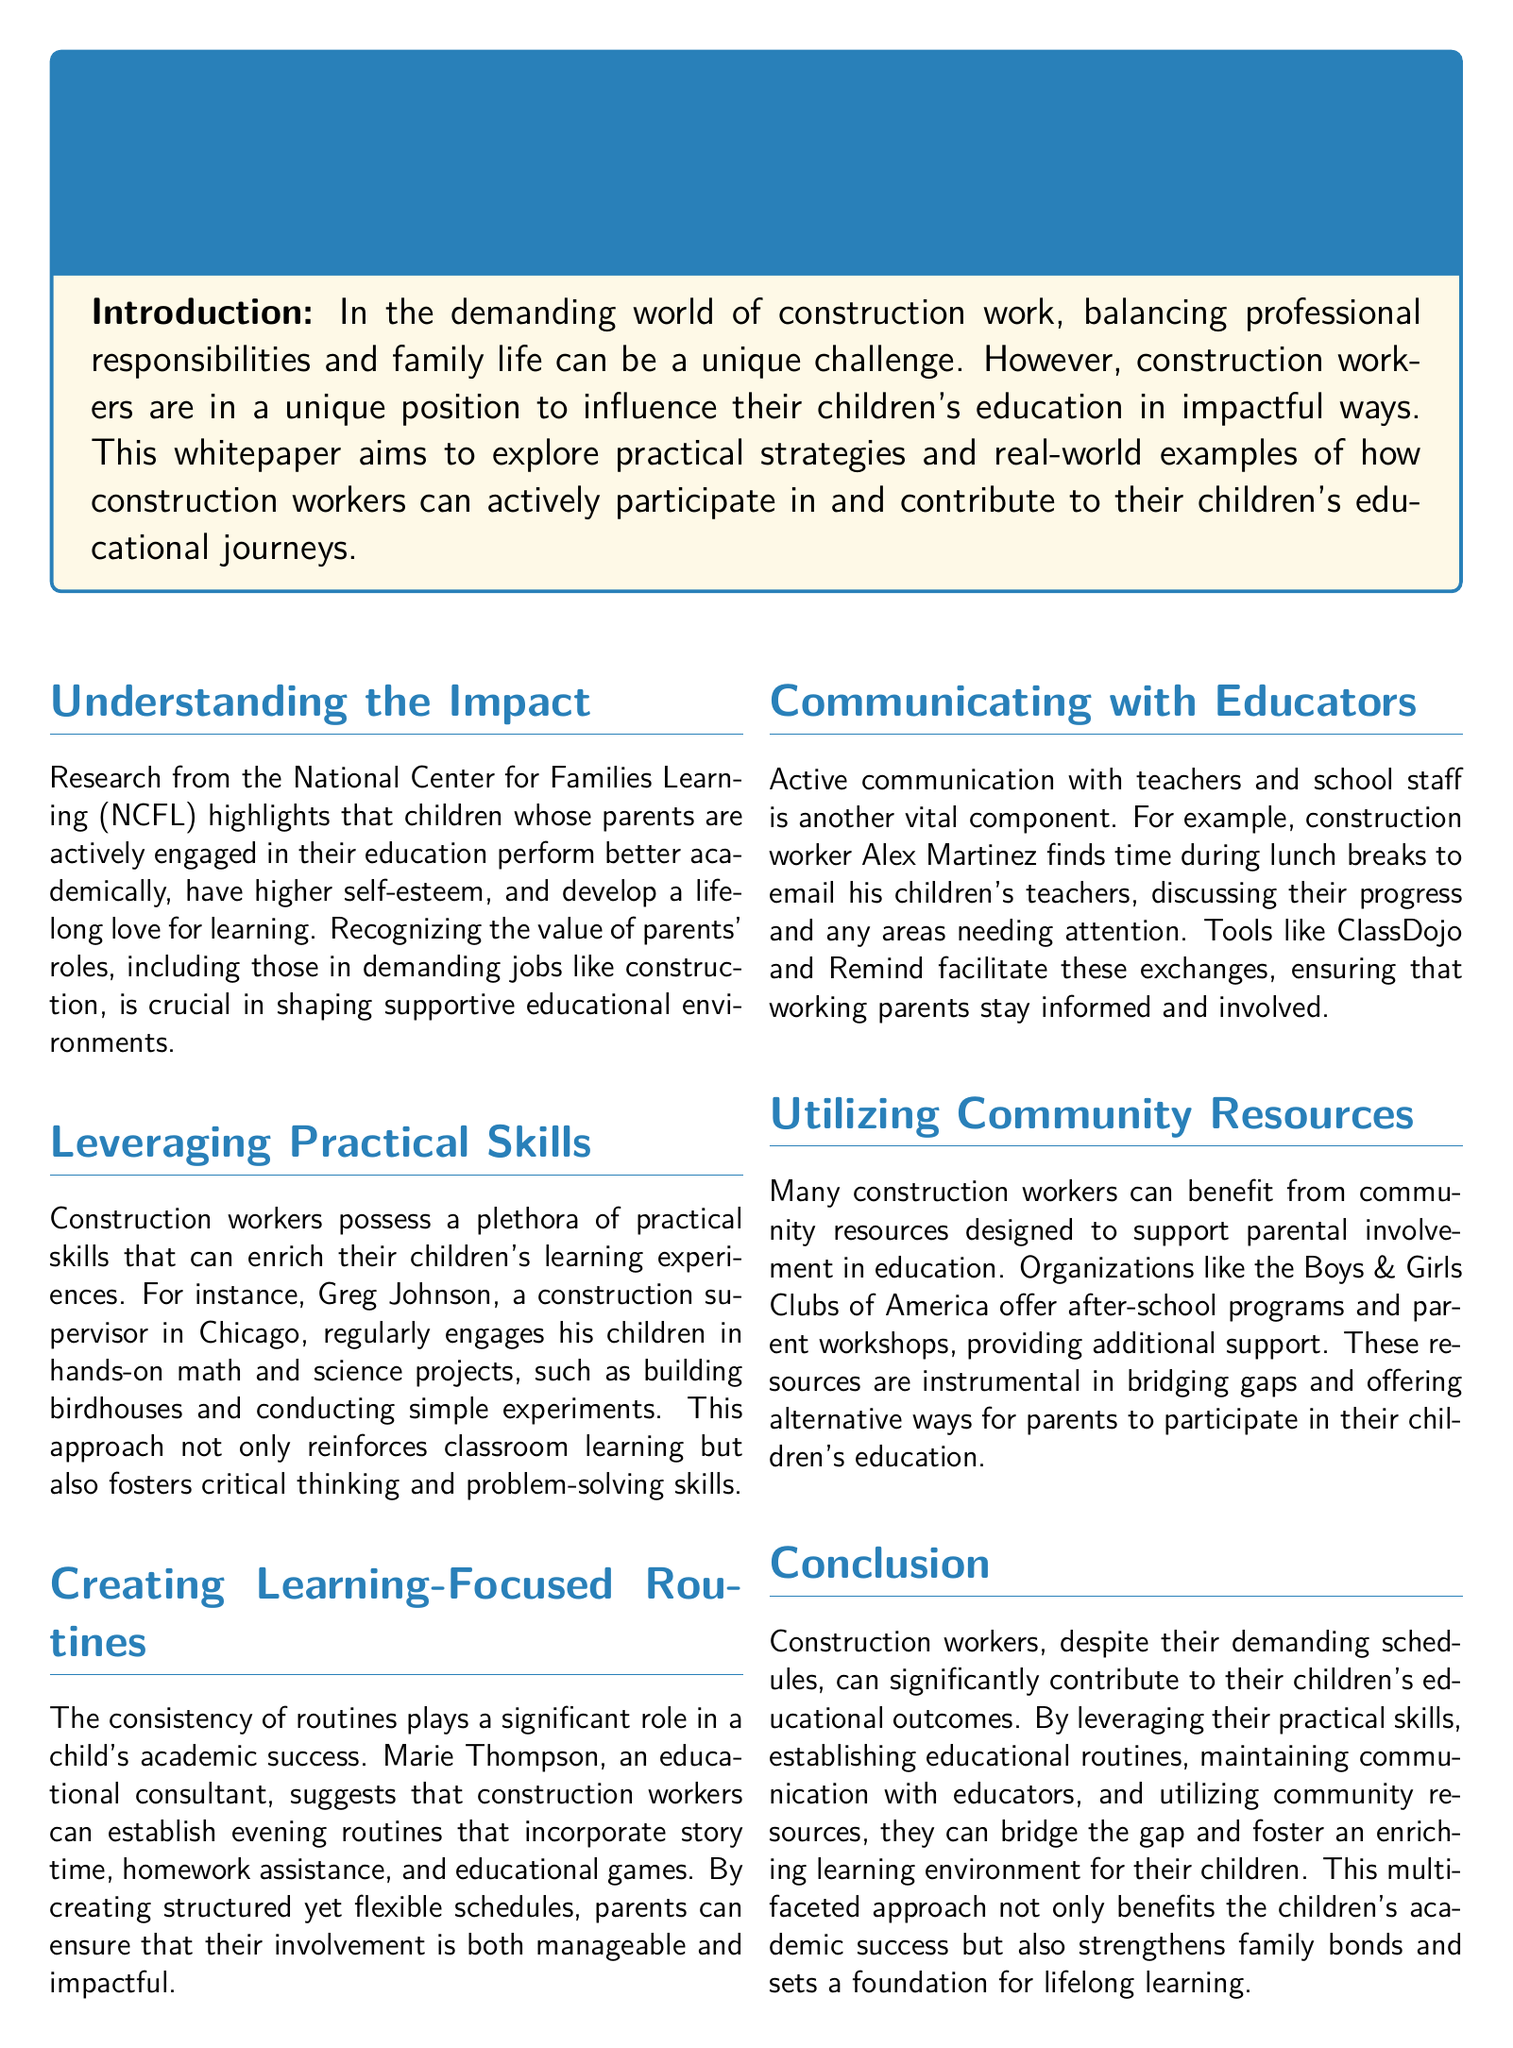what is the main topic of the whitepaper? The main topic is about how construction workers can engage in their children's education.
Answer: Bridging the Gap: How Construction Workers Can Play a Vital Role in Their Children's Education who conducted the research mentioned in the document? The research mentioned in the document was conducted by the National Center for Families Learning.
Answer: National Center for Families Learning (NCFL) what practical activities does Greg Johnson engage in with his children? Greg Johnson engages his children in hands-on math and science projects, such as building birdhouses.
Answer: Building birdhouses and conducting simple experiments what type of resource does the document suggest for community support? The document suggests after-school programs and parent workshops as community resources.
Answer: Boys & Girls Clubs of America who is the educational consultant mentioned in the whitepaper? The educational consultant mentioned is Marie Thompson.
Answer: Marie Thompson what tool does Alex Martinez use to communicate with teachers? Alex Martinez uses ClassDojo and Remind to communicate with teachers.
Answer: ClassDojo and Remind how do construction workers help establish routines for their children? They establish evening routines that include story time, homework assistance, and educational games.
Answer: Story time, homework assistance, and educational games what is one benefit of parental involvement in education according to the research? One benefit of parental involvement in education is that children perform better academically.
Answer: Perform better academically 